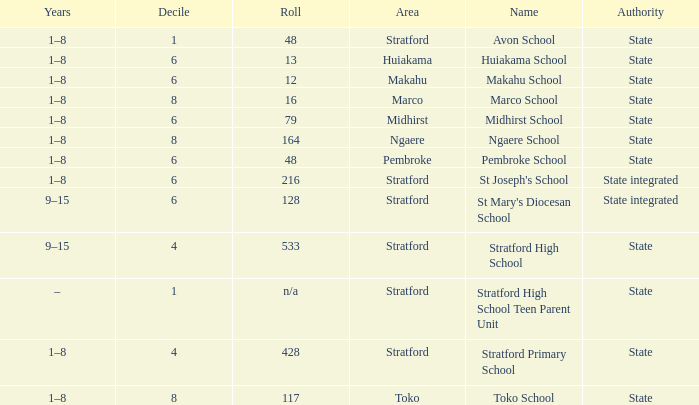What is the lowest decile with a state authority and Midhirst school? 6.0. 